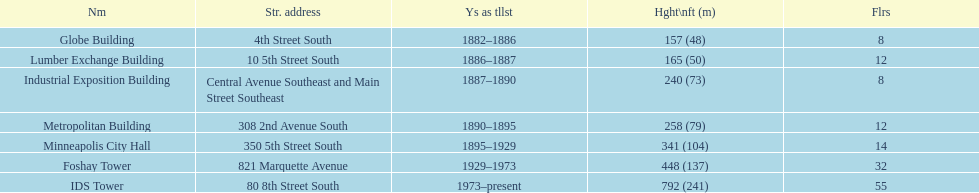Is the metropolitan building or the lumber exchange building taller? Metropolitan Building. 